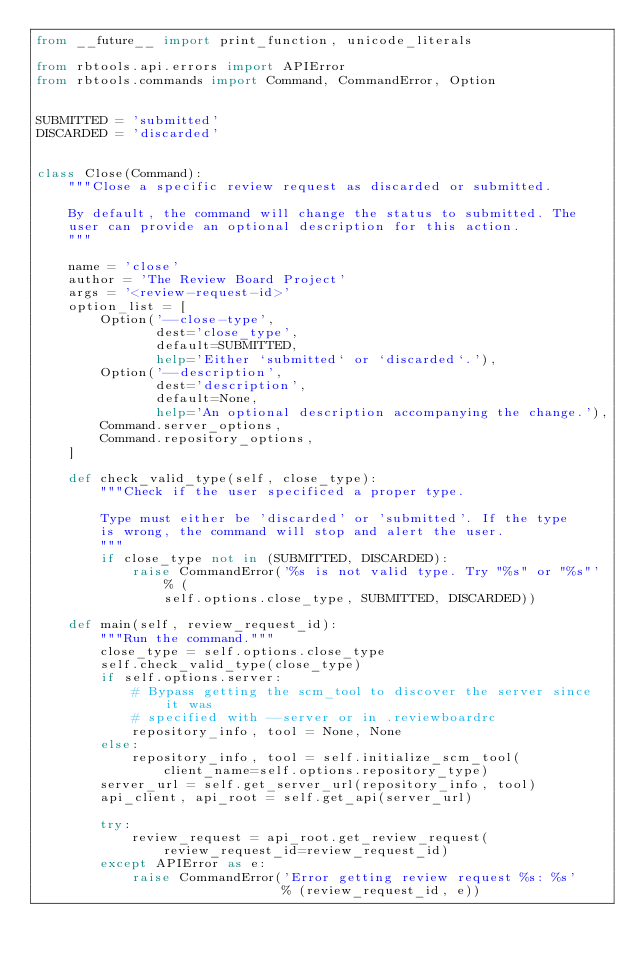Convert code to text. <code><loc_0><loc_0><loc_500><loc_500><_Python_>from __future__ import print_function, unicode_literals

from rbtools.api.errors import APIError
from rbtools.commands import Command, CommandError, Option


SUBMITTED = 'submitted'
DISCARDED = 'discarded'


class Close(Command):
    """Close a specific review request as discarded or submitted.

    By default, the command will change the status to submitted. The
    user can provide an optional description for this action.
    """

    name = 'close'
    author = 'The Review Board Project'
    args = '<review-request-id>'
    option_list = [
        Option('--close-type',
               dest='close_type',
               default=SUBMITTED,
               help='Either `submitted` or `discarded`.'),
        Option('--description',
               dest='description',
               default=None,
               help='An optional description accompanying the change.'),
        Command.server_options,
        Command.repository_options,
    ]

    def check_valid_type(self, close_type):
        """Check if the user specificed a proper type.

        Type must either be 'discarded' or 'submitted'. If the type
        is wrong, the command will stop and alert the user.
        """
        if close_type not in (SUBMITTED, DISCARDED):
            raise CommandError('%s is not valid type. Try "%s" or "%s"' % (
                self.options.close_type, SUBMITTED, DISCARDED))

    def main(self, review_request_id):
        """Run the command."""
        close_type = self.options.close_type
        self.check_valid_type(close_type)
        if self.options.server:
            # Bypass getting the scm_tool to discover the server since it was
            # specified with --server or in .reviewboardrc
            repository_info, tool = None, None
        else:
            repository_info, tool = self.initialize_scm_tool(
                client_name=self.options.repository_type)
        server_url = self.get_server_url(repository_info, tool)
        api_client, api_root = self.get_api(server_url)

        try:
            review_request = api_root.get_review_request(
                review_request_id=review_request_id)
        except APIError as e:
            raise CommandError('Error getting review request %s: %s'
                               % (review_request_id, e))
</code> 